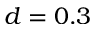Convert formula to latex. <formula><loc_0><loc_0><loc_500><loc_500>d = 0 . 3</formula> 